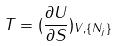<formula> <loc_0><loc_0><loc_500><loc_500>T = ( \frac { \partial U } { \partial S } ) _ { V , \{ N _ { j } \} }</formula> 